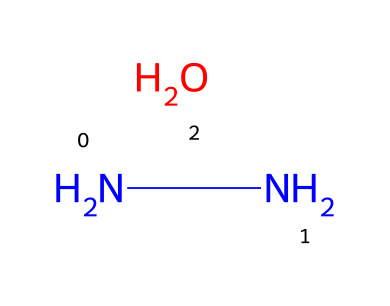What is the molecular formula for hydrazine hydrate? The SMILES representation indicates hydrazine (N2H4) and water (H2O) combined. The molecular formula combines these to yield N2H8O.
Answer: N2H8O How many nitrogen atoms are present in the structure? By analyzing the SMILES, there are two nitrogen atoms represented in the first part (N) before the hydration part (OH).
Answer: 2 What functional group can be found in this chemical? The presence of the -OH part (from water) indicates that this chemical contains a hydroxyl functional group.
Answer: hydroxyl What is the total number of hydrogen atoms in hydrazine hydrate? Adding the hydrogen atoms from hydrazine (4 H) and water (2 H) gives a total of 6 H from hydrazine plus 2 from water, which = 8 H atoms.
Answer: 8 Is hydrazine hydrate a strong or weak reducing agent? As a hydrazine derivative, it is generally considered a strong reducing agent due to the electron-donating ability of nitrogen.
Answer: strong What type of chemical is hydrazine hydrate classified as? The presence of the nitrogen-nitrogen bond in conjunction with the attached water molecule identifies hydrazine hydrate as a hydrazine compound.
Answer: hydrazine What is the bond type between the nitrogen atoms? The SMILES notation shows the arrangement of N atoms with a single bond (as denoted in chemical structure).
Answer: single bond 